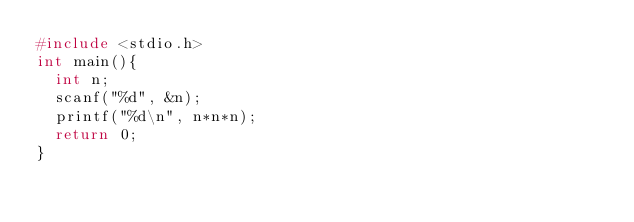<code> <loc_0><loc_0><loc_500><loc_500><_C_>#include <stdio.h>
int main(){
  int n;
  scanf("%d", &n);
  printf("%d\n", n*n*n);
  return 0;
}
</code> 